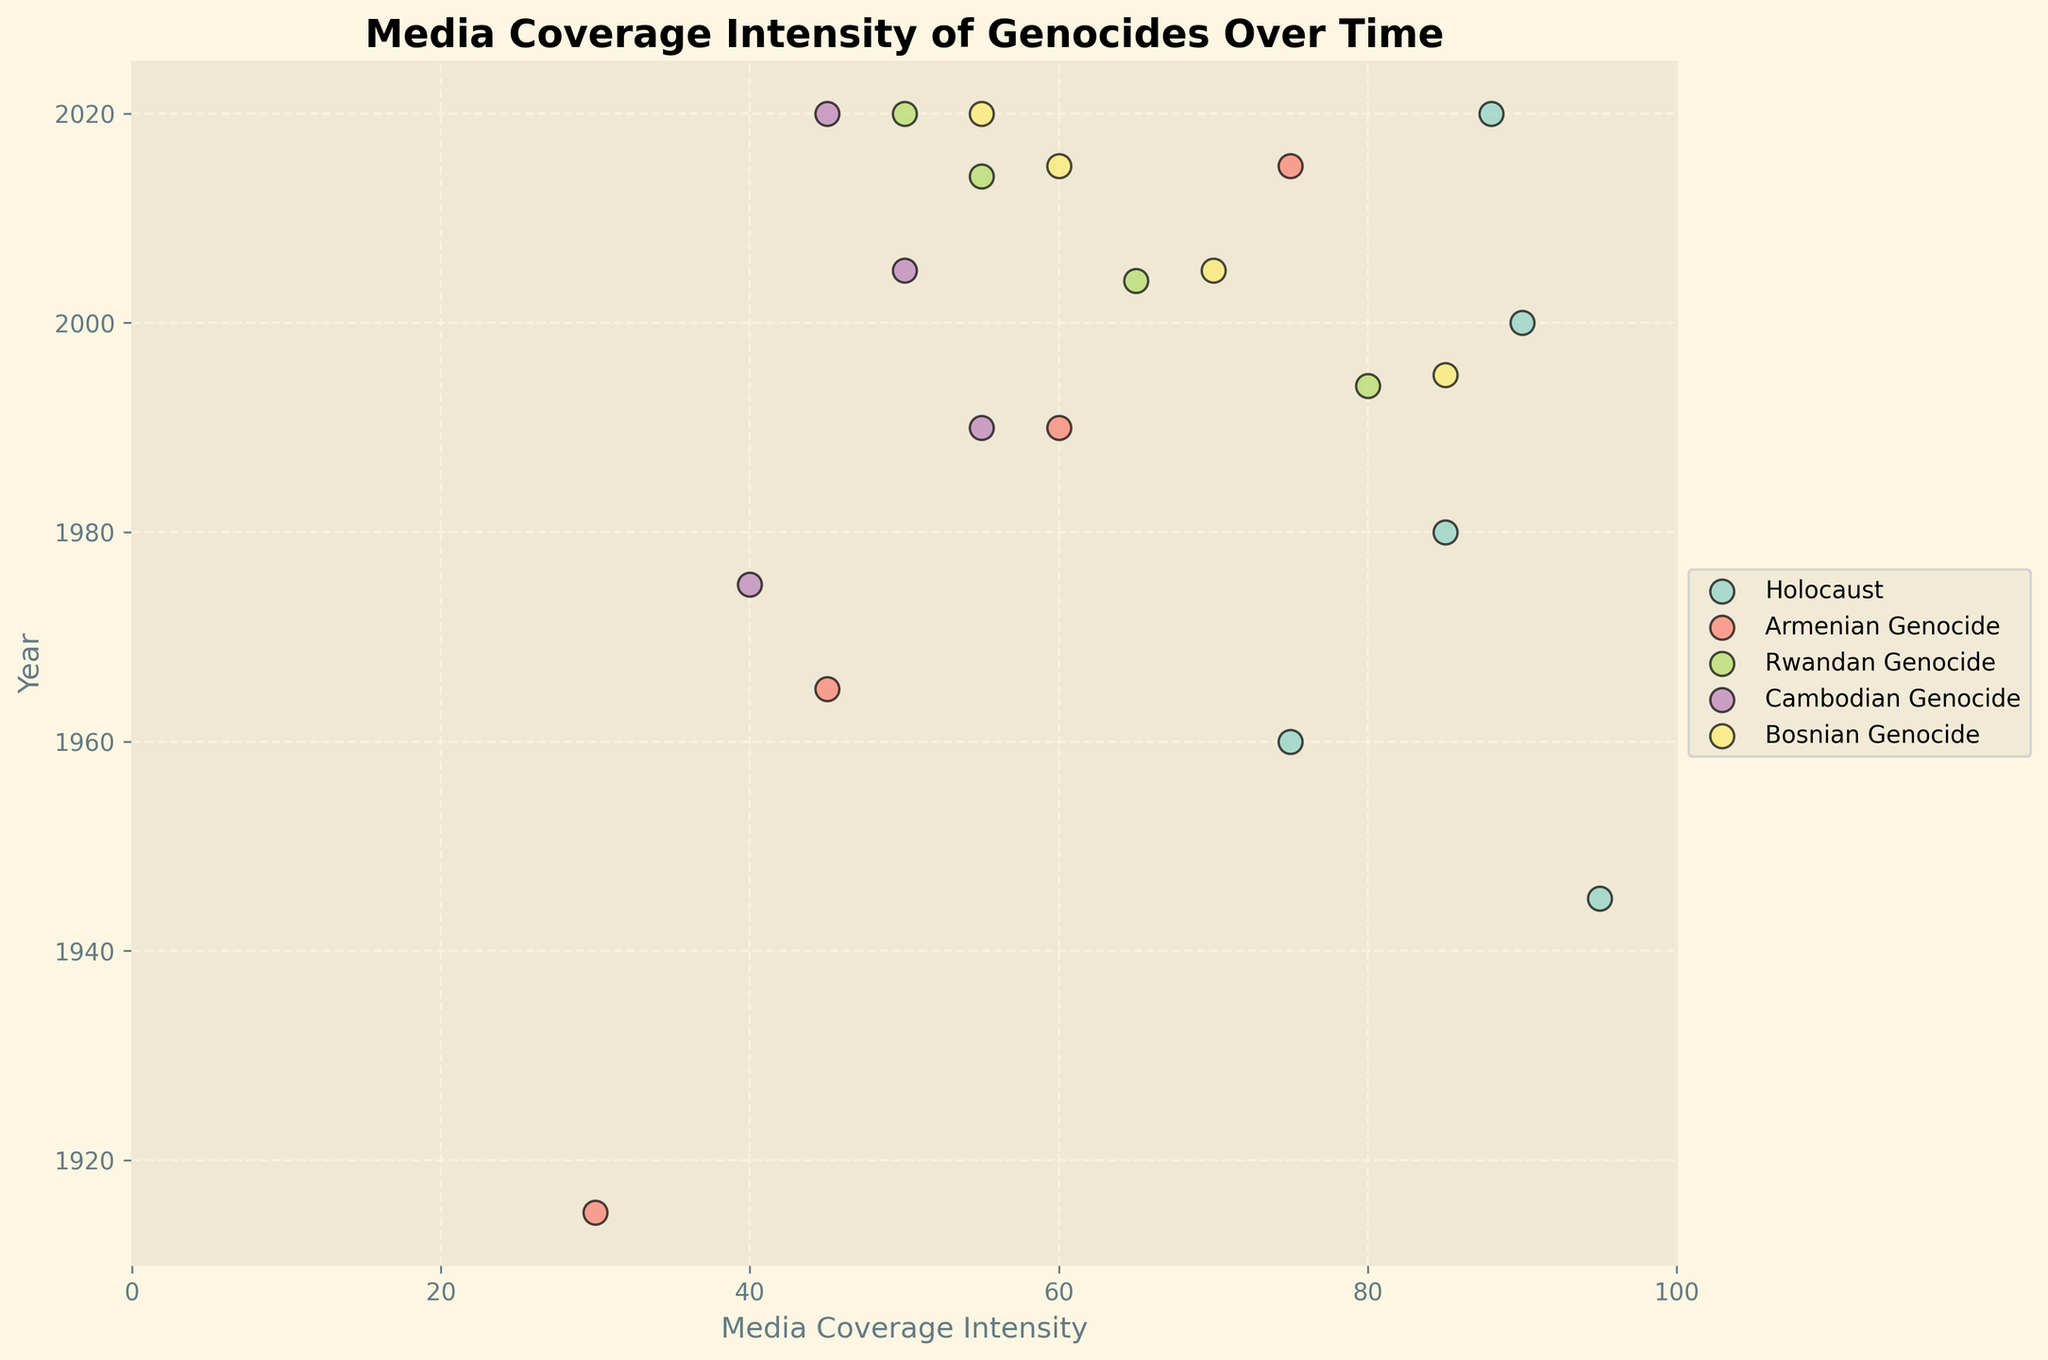What is the title of the plot? The plot title is typically located at the top center of the figure and summarizes the content of the plot. The title in this case reads 'Media Coverage Intensity of Genocides Over Time'.
Answer: Media Coverage Intensity of Genocides Over Time Which genocide has the highest media coverage intensity in the most recent year (2020)? To find this, look for the point corresponding to 2020 for each genocide and compare their media coverage intensities. The Holocaust has the highest media coverage intensity in 2020 at 88.
Answer: Holocaust What is the range of years covered in this figure? The years can be found on the vertical axis (y-axis). The first year listed is 1915 and the last year listed is 2020.
Answer: 1915-2020 Which genocide's media coverage showed the most consistent increase over time? To determine this, observe the trend lines connecting points for each genocide. The Armenian Genocide shows the most consistent increase, starting at 30 in 1915 and rising steadily to 75 in 2015.
Answer: Armenian Genocide Which genocide had the highest peak media coverage intensity and in what year? Compare the highest points for each genocide on the plot. The Holocaust had the highest peak media coverage intensity of 95 in 1945.
Answer: Holocaust in 1945 How does the media coverage intensity of the Rwandan Genocide change over time? Look at the data points for the Rwandan Genocide across different years. It starts at 80 in 1994, decreasing to 65 in 2004, 55 in 2014, and 50 in 2020.
Answer: It decreases over time Which two genocides had the closest media coverage intensity in 2020? Compare the 2020 data points for each genocide. The Cambodian Genocide (45) and Bosnian Genocide (55) had the closest media coverage intensities.
Answer: Cambodian Genocide and Bosnian Genocide In which decade did the media coverage intensity for the Bosnian Genocide decrease the most? Observe the change in media coverage values for the Bosnian Genocide over each decade. Between 1995 (85) and 2005 (70), the decrease was 15 units, which is the largest.
Answer: 1995-2005 What is the average media coverage intensity for the Holocaust over all recorded years? Add the media coverage intensities for the Holocaust and divide by the number of recorded years: (95+75+85+90+88)/5. Therefore, the average is 86.6.
Answer: 86.6 Which decade shows the highest media coverage intensity for the Cambodian Genocide? Identify the decade with the highest data point for the Cambodian Genocide. The highest point is in 1990 with a value of 55.
Answer: 1990 